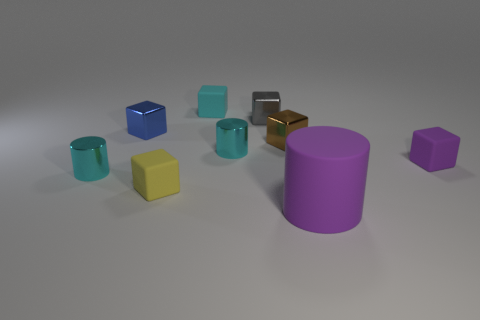Are the small cylinder that is right of the small blue cube and the small cylinder on the left side of the yellow rubber object made of the same material?
Provide a succinct answer. Yes. What material is the cyan cylinder in front of the block that is right of the tiny brown shiny cube made of?
Ensure brevity in your answer.  Metal. Does the tiny object to the right of the tiny brown shiny thing have the same shape as the thing behind the gray object?
Give a very brief answer. Yes. How big is the cube that is to the right of the yellow rubber thing and on the left side of the gray shiny thing?
Ensure brevity in your answer.  Small. What number of other objects are the same color as the big rubber thing?
Your answer should be very brief. 1. Do the cyan thing that is left of the tiny cyan matte block and the tiny purple object have the same material?
Keep it short and to the point. No. Is there any other thing that is the same size as the purple rubber cylinder?
Your response must be concise. No. Are there fewer purple rubber cylinders on the right side of the large rubber cylinder than small gray cubes in front of the tiny purple rubber cube?
Offer a very short reply. No. There is a small cyan metallic object that is right of the small cyan object that is on the left side of the tiny blue object; how many small metallic cylinders are on the left side of it?
Offer a very short reply. 1. There is a tiny brown metallic block; how many tiny things are in front of it?
Offer a terse response. 4. 